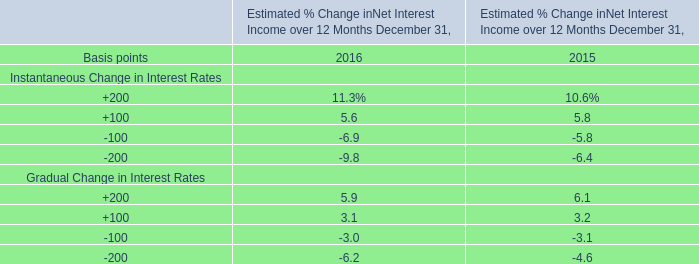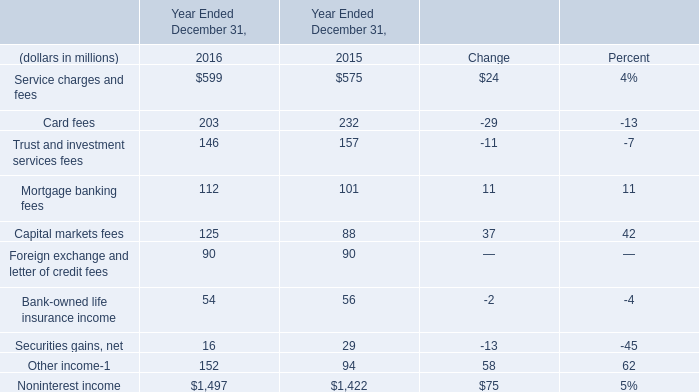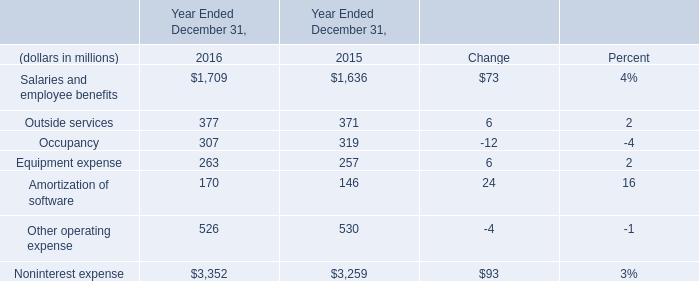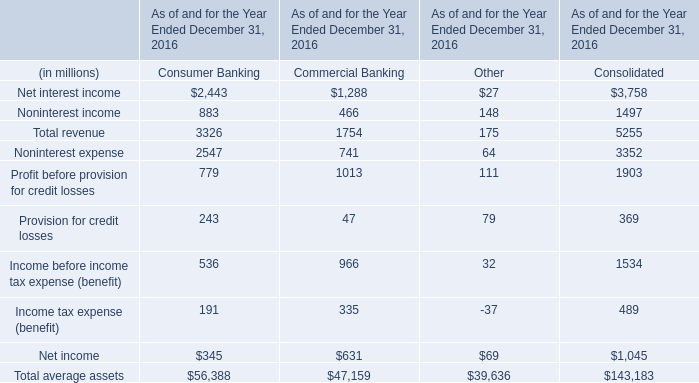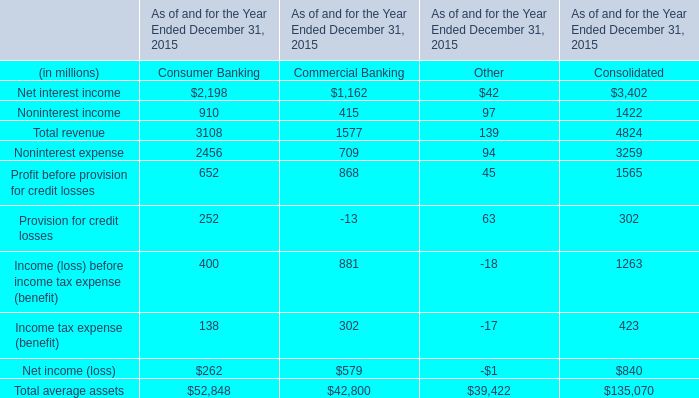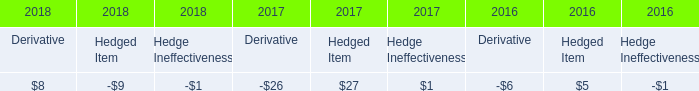What was the average value of the Outside services and Occupancy in the years where Salaries and employee benefits is positive? (in million) 
Computations: (377 + 307)
Answer: 684.0. 